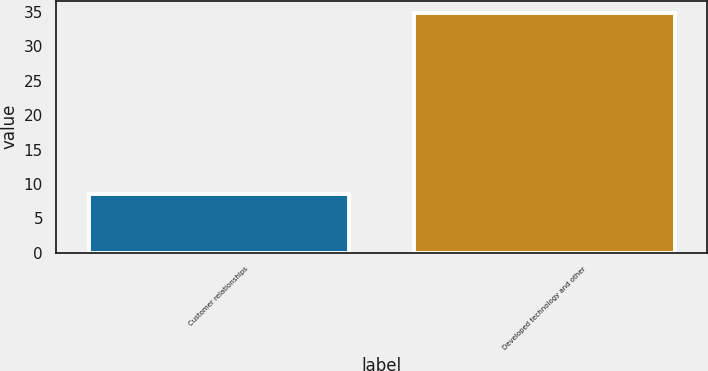<chart> <loc_0><loc_0><loc_500><loc_500><bar_chart><fcel>Customer relationships<fcel>Developed technology and other<nl><fcel>8.5<fcel>34.9<nl></chart> 